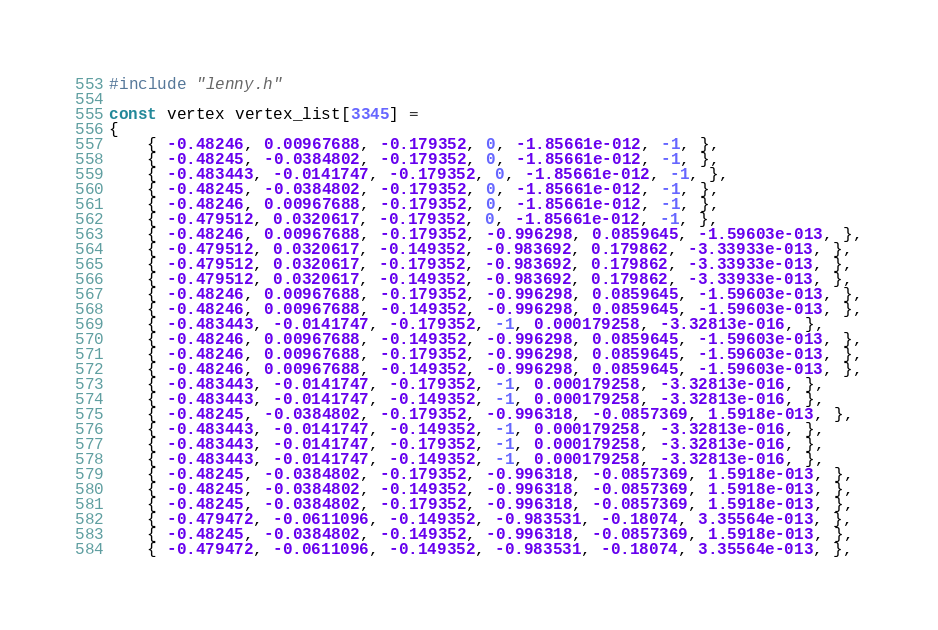Convert code to text. <code><loc_0><loc_0><loc_500><loc_500><_C_>#include "lenny.h"

const vertex vertex_list[3345] = 
{
	{ -0.48246, 0.00967688, -0.179352, 0, -1.85661e-012, -1, },
	{ -0.48245, -0.0384802, -0.179352, 0, -1.85661e-012, -1, },
	{ -0.483443, -0.0141747, -0.179352, 0, -1.85661e-012, -1, },
	{ -0.48245, -0.0384802, -0.179352, 0, -1.85661e-012, -1, },
	{ -0.48246, 0.00967688, -0.179352, 0, -1.85661e-012, -1, },
	{ -0.479512, 0.0320617, -0.179352, 0, -1.85661e-012, -1, },
	{ -0.48246, 0.00967688, -0.179352, -0.996298, 0.0859645, -1.59603e-013, },
	{ -0.479512, 0.0320617, -0.149352, -0.983692, 0.179862, -3.33933e-013, },
	{ -0.479512, 0.0320617, -0.179352, -0.983692, 0.179862, -3.33933e-013, },
	{ -0.479512, 0.0320617, -0.149352, -0.983692, 0.179862, -3.33933e-013, },
	{ -0.48246, 0.00967688, -0.179352, -0.996298, 0.0859645, -1.59603e-013, },
	{ -0.48246, 0.00967688, -0.149352, -0.996298, 0.0859645, -1.59603e-013, },
	{ -0.483443, -0.0141747, -0.179352, -1, 0.000179258, -3.32813e-016, },
	{ -0.48246, 0.00967688, -0.149352, -0.996298, 0.0859645, -1.59603e-013, },
	{ -0.48246, 0.00967688, -0.179352, -0.996298, 0.0859645, -1.59603e-013, },
	{ -0.48246, 0.00967688, -0.149352, -0.996298, 0.0859645, -1.59603e-013, },
	{ -0.483443, -0.0141747, -0.179352, -1, 0.000179258, -3.32813e-016, },
	{ -0.483443, -0.0141747, -0.149352, -1, 0.000179258, -3.32813e-016, },
	{ -0.48245, -0.0384802, -0.179352, -0.996318, -0.0857369, 1.5918e-013, },
	{ -0.483443, -0.0141747, -0.149352, -1, 0.000179258, -3.32813e-016, },
	{ -0.483443, -0.0141747, -0.179352, -1, 0.000179258, -3.32813e-016, },
	{ -0.483443, -0.0141747, -0.149352, -1, 0.000179258, -3.32813e-016, },
	{ -0.48245, -0.0384802, -0.179352, -0.996318, -0.0857369, 1.5918e-013, },
	{ -0.48245, -0.0384802, -0.149352, -0.996318, -0.0857369, 1.5918e-013, },
	{ -0.48245, -0.0384802, -0.179352, -0.996318, -0.0857369, 1.5918e-013, },
	{ -0.479472, -0.0611096, -0.149352, -0.983531, -0.18074, 3.35564e-013, },
	{ -0.48245, -0.0384802, -0.149352, -0.996318, -0.0857369, 1.5918e-013, },
	{ -0.479472, -0.0611096, -0.149352, -0.983531, -0.18074, 3.35564e-013, },</code> 